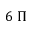Convert formula to latex. <formula><loc_0><loc_0><loc_500><loc_500>6 \, \Pi</formula> 